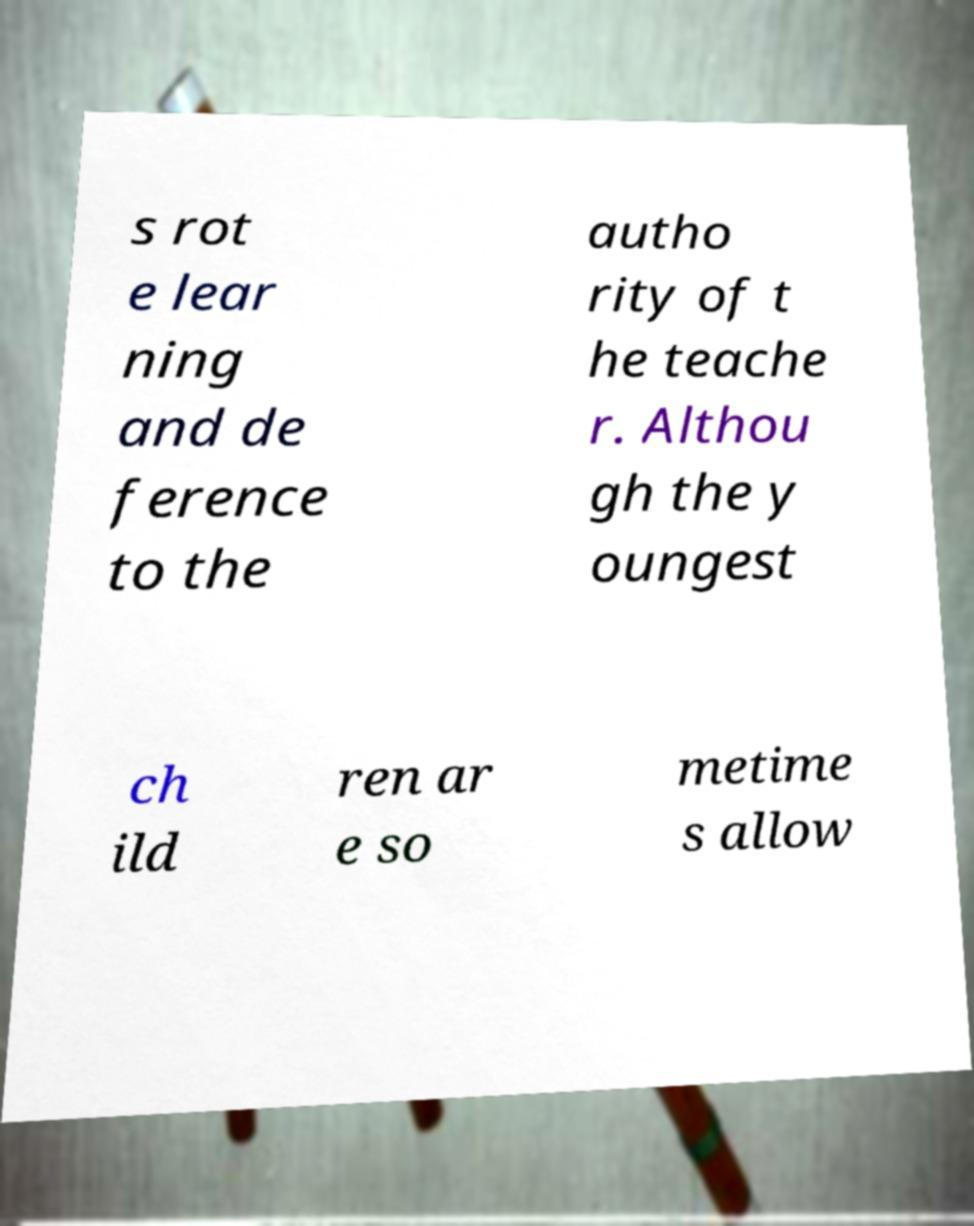Could you extract and type out the text from this image? s rot e lear ning and de ference to the autho rity of t he teache r. Althou gh the y oungest ch ild ren ar e so metime s allow 